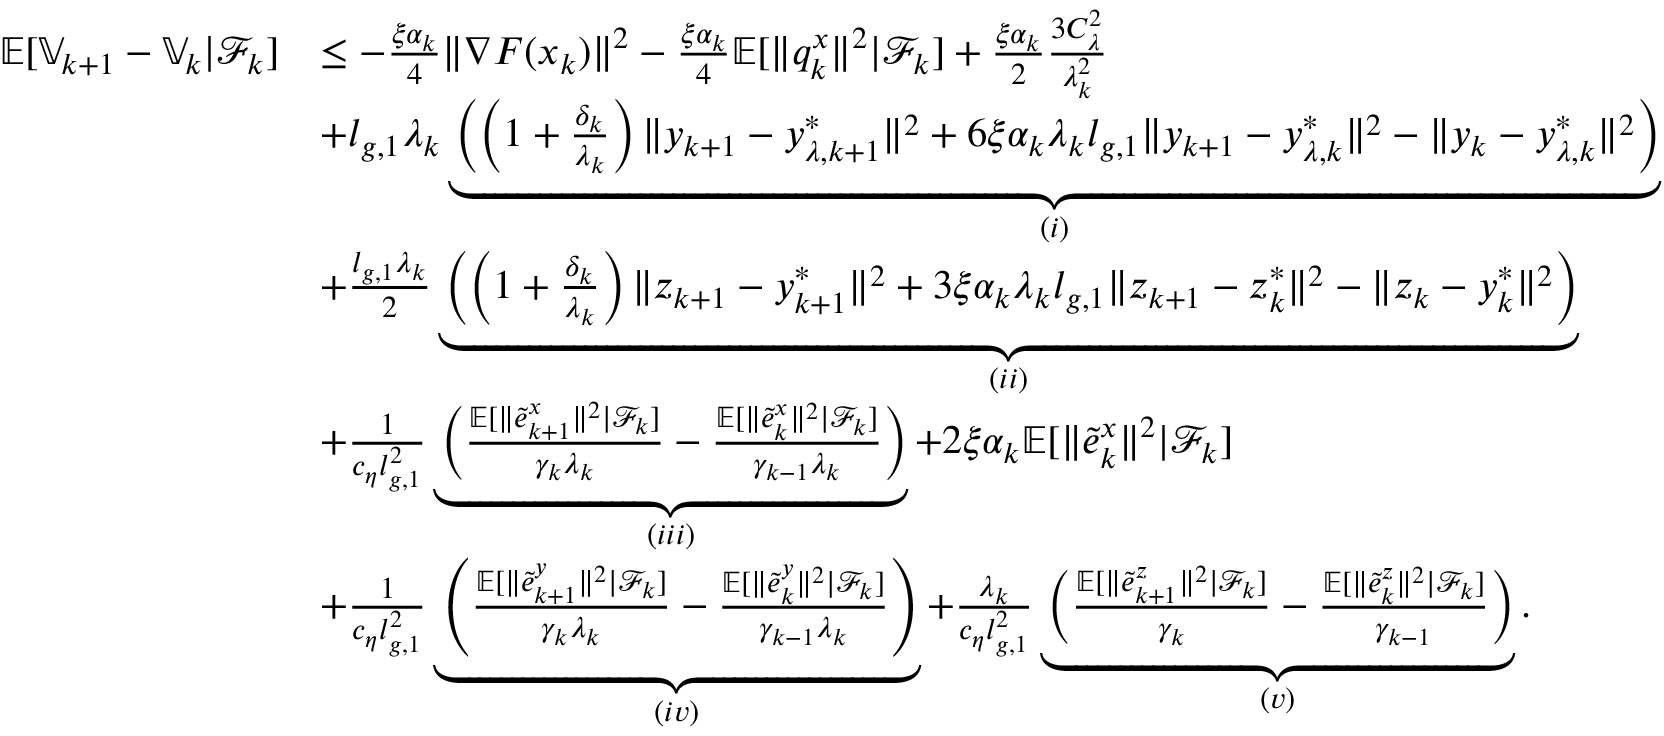Convert formula to latex. <formula><loc_0><loc_0><loc_500><loc_500>\begin{array} { r l } { \mathbb { E } [ \mathbb { V } _ { k + 1 } - \mathbb { V } _ { k } | \mathcal { F } _ { k } ] } & { \leq - \frac { \xi \alpha _ { k } } { 4 } \| \nabla F ( x _ { k } ) \| ^ { 2 } - \frac { \xi \alpha _ { k } } { 4 } \mathbb { E } [ \| q _ { k } ^ { x } \| ^ { 2 } | \mathcal { F } _ { k } ] + \frac { \xi \alpha _ { k } } { 2 } \frac { 3 C _ { \lambda } ^ { 2 } } { \lambda _ { k } ^ { 2 } } } \\ & { + l _ { g , 1 } \lambda _ { k } \underbrace { \left ( \left ( 1 + \frac { \delta _ { k } } { \lambda _ { k } } \right ) \| y _ { k + 1 } - y _ { \lambda , k + 1 } ^ { * } \| ^ { 2 } + 6 \xi \alpha _ { k } \lambda _ { k } l _ { g , 1 } \| y _ { k + 1 } - y _ { \lambda , k } ^ { * } \| ^ { 2 } - \| y _ { k } - y _ { \lambda , k } ^ { * } \| ^ { 2 } \right ) } _ { ( i ) } } \\ & { + \frac { l _ { g , 1 } \lambda _ { k } } { 2 } \underbrace { \left ( \left ( 1 + \frac { \delta _ { k } } { \lambda _ { k } } \right ) \| z _ { k + 1 } - y _ { k + 1 } ^ { * } \| ^ { 2 } + 3 \xi \alpha _ { k } \lambda _ { k } l _ { g , 1 } \| z _ { k + 1 } - z _ { k } ^ { * } \| ^ { 2 } - \| z _ { k } - y _ { k } ^ { * } \| ^ { 2 } \right ) } _ { ( i i ) } } \\ & { + \frac { 1 } { c _ { \eta } l _ { g , 1 } ^ { 2 } } \underbrace { \left ( \frac { \mathbb { E } [ \| \tilde { e } _ { k + 1 } ^ { x } \| ^ { 2 } | \mathcal { F } _ { k } ] } { \gamma _ { k } \lambda _ { k } } - \frac { \mathbb { E } [ \| \tilde { e } _ { k } ^ { x } \| ^ { 2 } | \mathcal { F } _ { k } ] } { \gamma _ { k - 1 } \lambda _ { k } } \right ) } _ { ( i i i ) } + 2 \xi \alpha _ { k } \mathbb { E } [ \| \tilde { e } _ { k } ^ { x } \| ^ { 2 } | \mathcal { F } _ { k } ] } \\ & { + \frac { 1 } { c _ { \eta } l _ { g , 1 } ^ { 2 } } \underbrace { \left ( \frac { \mathbb { E } [ \| \tilde { e } _ { k + 1 } ^ { y } \| ^ { 2 } | \mathcal { F } _ { k } ] } { \gamma _ { k } \lambda _ { k } } - \frac { \mathbb { E } [ \| \tilde { e } _ { k } ^ { y } \| ^ { 2 } | \mathcal { F } _ { k } ] } { \gamma _ { k - 1 } \lambda _ { k } } \right ) } _ { ( i v ) } + \frac { \lambda _ { k } } { c _ { \eta } l _ { g , 1 } ^ { 2 } } \underbrace { \left ( \frac { \mathbb { E } [ \| \tilde { e } _ { k + 1 } ^ { z } \| ^ { 2 } | \mathcal { F } _ { k } ] } { \gamma _ { k } } - \frac { \mathbb { E } [ \| \tilde { e } _ { k } ^ { z } \| ^ { 2 } | \mathcal { F } _ { k } ] } { \gamma _ { k - 1 } } \right ) } _ { ( v ) } . } \end{array}</formula> 